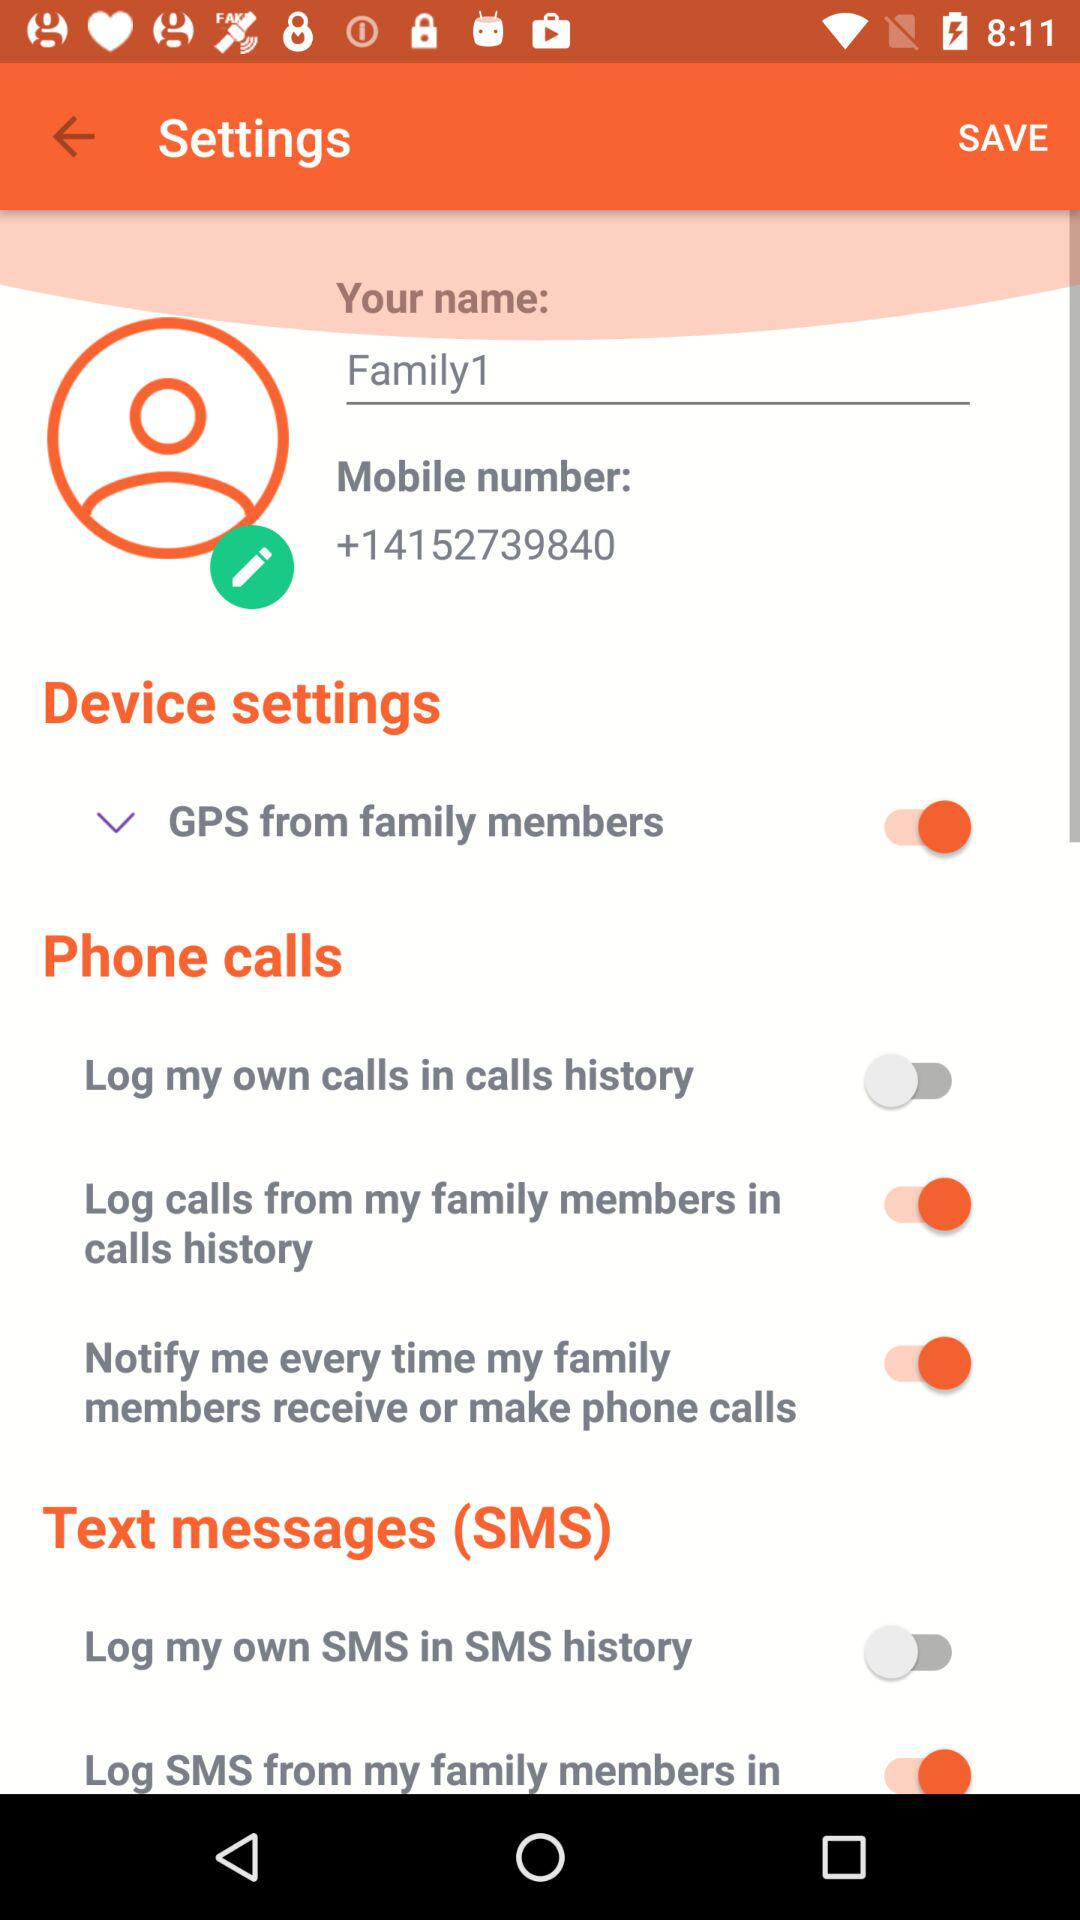What is the current status of "Log my own SMS in SMS history"? The status is "off". 